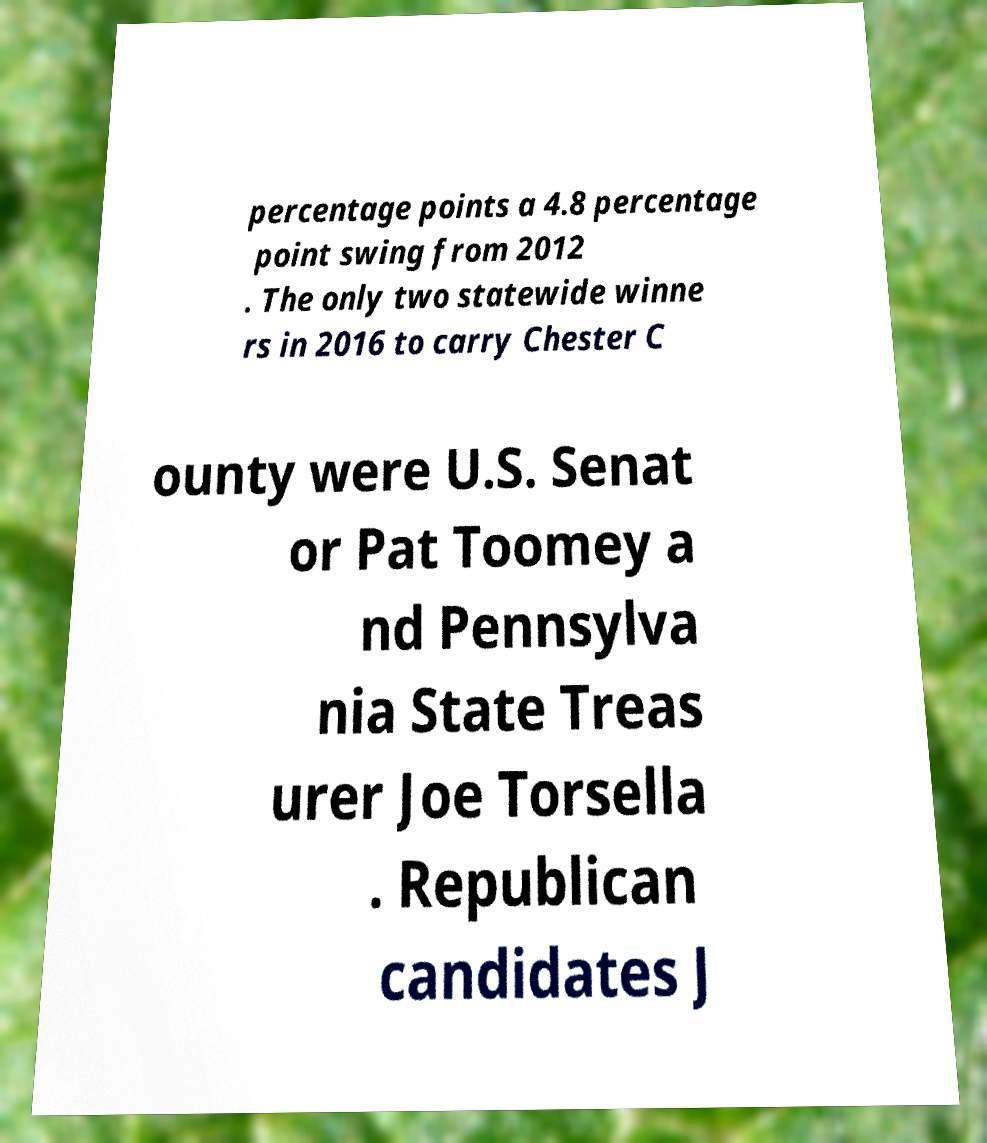Please identify and transcribe the text found in this image. percentage points a 4.8 percentage point swing from 2012 . The only two statewide winne rs in 2016 to carry Chester C ounty were U.S. Senat or Pat Toomey a nd Pennsylva nia State Treas urer Joe Torsella . Republican candidates J 